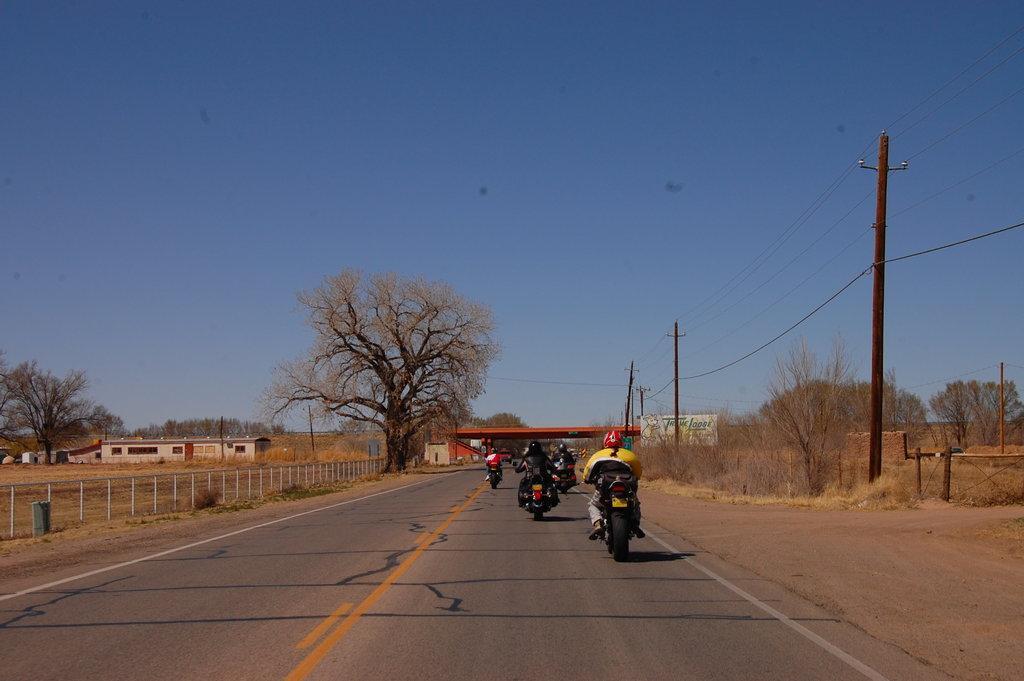How would you summarize this image in a sentence or two? In this image, we can see a few vehicles. We can see the ground. We can see some grass, dried plants. There are a few poles with wires. We can see a board with some text. We can see some houses. We can see a bridge and we can see the sky. There are a few trees. 